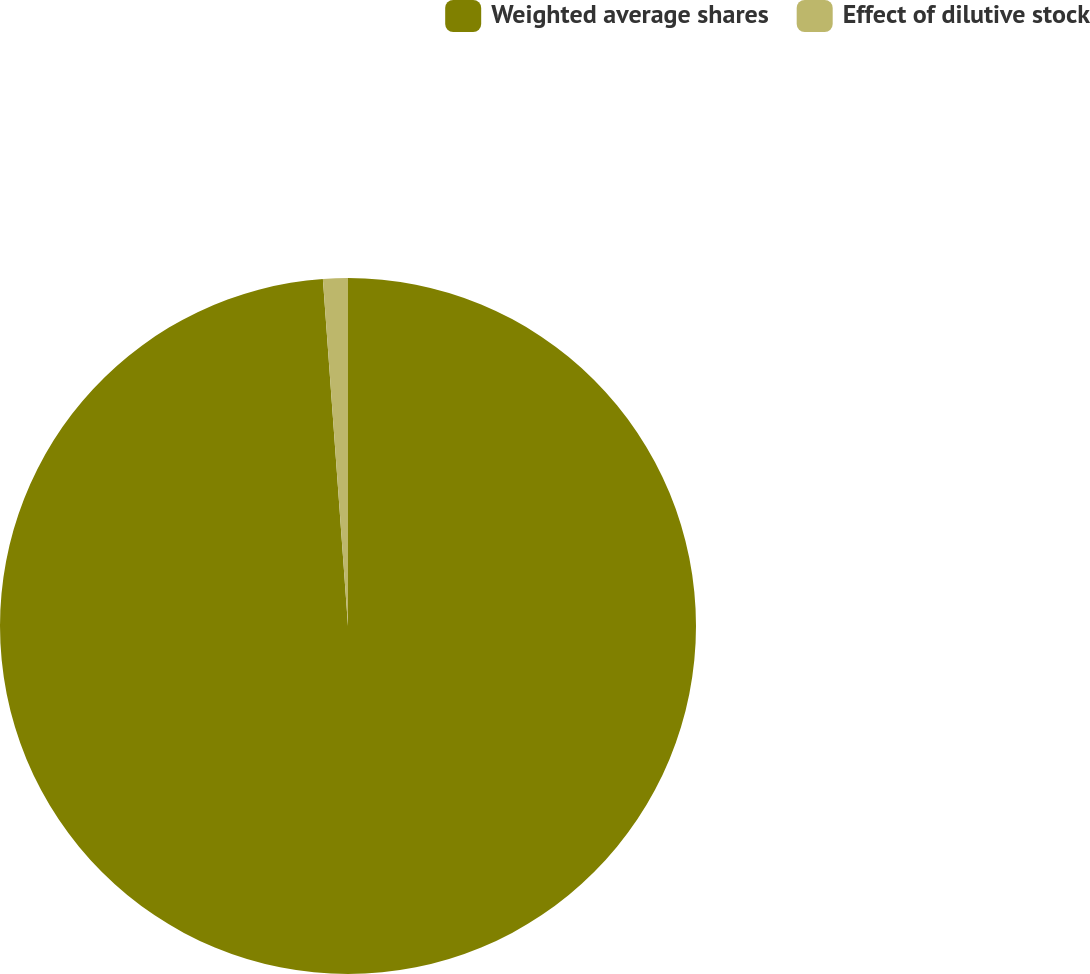Convert chart to OTSL. <chart><loc_0><loc_0><loc_500><loc_500><pie_chart><fcel>Weighted average shares<fcel>Effect of dilutive stock<nl><fcel>98.85%<fcel>1.15%<nl></chart> 